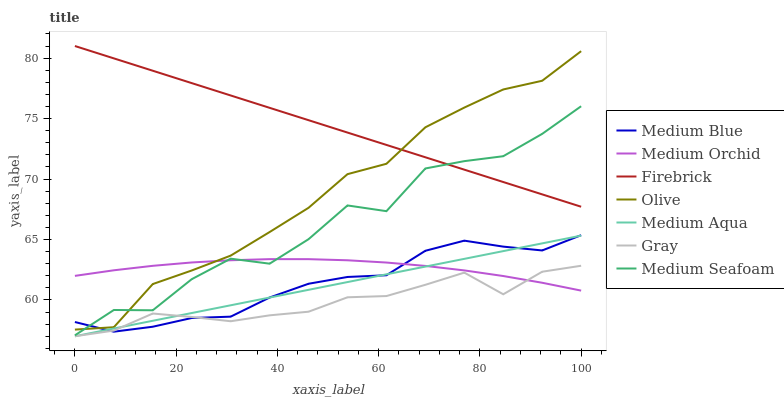Does Gray have the minimum area under the curve?
Answer yes or no. Yes. Does Firebrick have the maximum area under the curve?
Answer yes or no. Yes. Does Medium Orchid have the minimum area under the curve?
Answer yes or no. No. Does Medium Orchid have the maximum area under the curve?
Answer yes or no. No. Is Medium Aqua the smoothest?
Answer yes or no. Yes. Is Medium Seafoam the roughest?
Answer yes or no. Yes. Is Firebrick the smoothest?
Answer yes or no. No. Is Firebrick the roughest?
Answer yes or no. No. Does Gray have the lowest value?
Answer yes or no. Yes. Does Medium Orchid have the lowest value?
Answer yes or no. No. Does Firebrick have the highest value?
Answer yes or no. Yes. Does Medium Orchid have the highest value?
Answer yes or no. No. Is Medium Aqua less than Firebrick?
Answer yes or no. Yes. Is Olive greater than Medium Aqua?
Answer yes or no. Yes. Does Medium Blue intersect Olive?
Answer yes or no. Yes. Is Medium Blue less than Olive?
Answer yes or no. No. Is Medium Blue greater than Olive?
Answer yes or no. No. Does Medium Aqua intersect Firebrick?
Answer yes or no. No. 